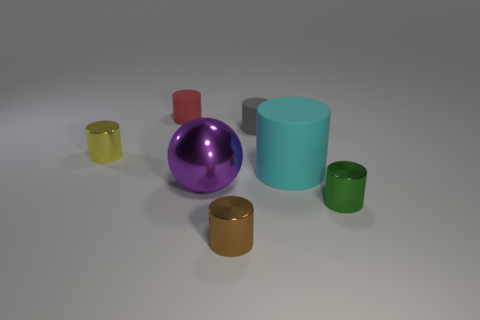Are there fewer big rubber objects than large gray metallic cubes?
Offer a terse response. No. There is a tiny red rubber thing; is its shape the same as the tiny metallic thing that is behind the big purple metallic sphere?
Ensure brevity in your answer.  Yes. There is a metallic cylinder that is behind the purple object; is its size the same as the ball?
Your response must be concise. No. There is a yellow shiny object that is the same size as the brown shiny cylinder; what is its shape?
Provide a short and direct response. Cylinder. Is the red matte object the same shape as the large metal object?
Keep it short and to the point. No. What number of small gray objects have the same shape as the green shiny object?
Offer a very short reply. 1. There is a small yellow object; what number of tiny gray rubber objects are behind it?
Provide a succinct answer. 1. Do the large object behind the purple metal ball and the sphere have the same color?
Your answer should be compact. No. What number of yellow matte balls have the same size as the red rubber cylinder?
Ensure brevity in your answer.  0. What is the shape of the tiny red object that is the same material as the big cylinder?
Offer a very short reply. Cylinder. 